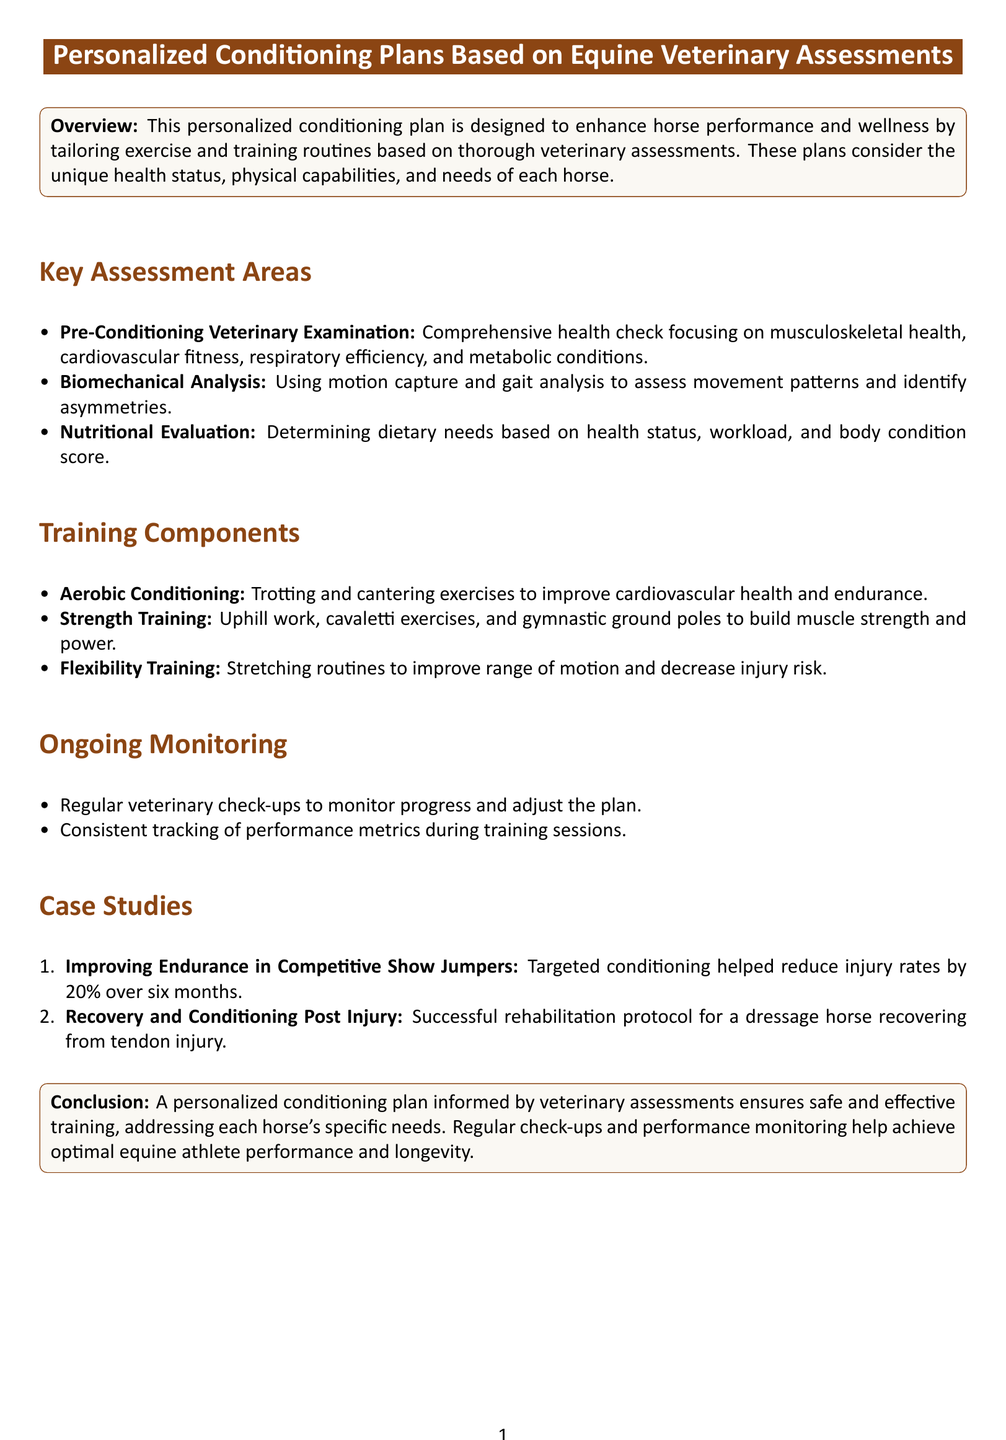What is the main purpose of the personalized conditioning plan? The main purpose is to enhance horse performance and wellness by tailoring exercise and training routines based on veterinary assessments.
Answer: Enhance horse performance and wellness What are the three key assessment areas mentioned? The key assessment areas are Pre-Conditioning Veterinary Examination, Biomechanical Analysis, and Nutritional Evaluation.
Answer: Pre-Conditioning Veterinary Examination, Biomechanical Analysis, Nutritional Evaluation What type of training is included for cardiovascular health? The document states aerobic conditioning focuses on trotting and cantering exercises to improve cardiovascular health.
Answer: Aerobic conditioning What is one example of a case study in the document? The document mentions a case study regarding improving endurance in competitive show jumpers and its results.
Answer: Improving endurance in competitive show jumpers How much did injury rates reduce in the case study about competitive show jumpers? The case study reports that injury rates reduced by 20% over six months.
Answer: 20% What does ongoing monitoring include? Ongoing monitoring includes regular veterinary check-ups and consistent tracking of performance metrics.
Answer: Regular veterinary check-ups, performance metrics tracking What is the concluding message of the document? The document concludes that personalized plans ensure safe and effective training tailored to each horse's needs.
Answer: Safe and effective training What should be adjusted based on regular check-ups? The document states that the personalized conditioning plan should be adjusted based on regular check-ups.
Answer: The personalized conditioning plan 